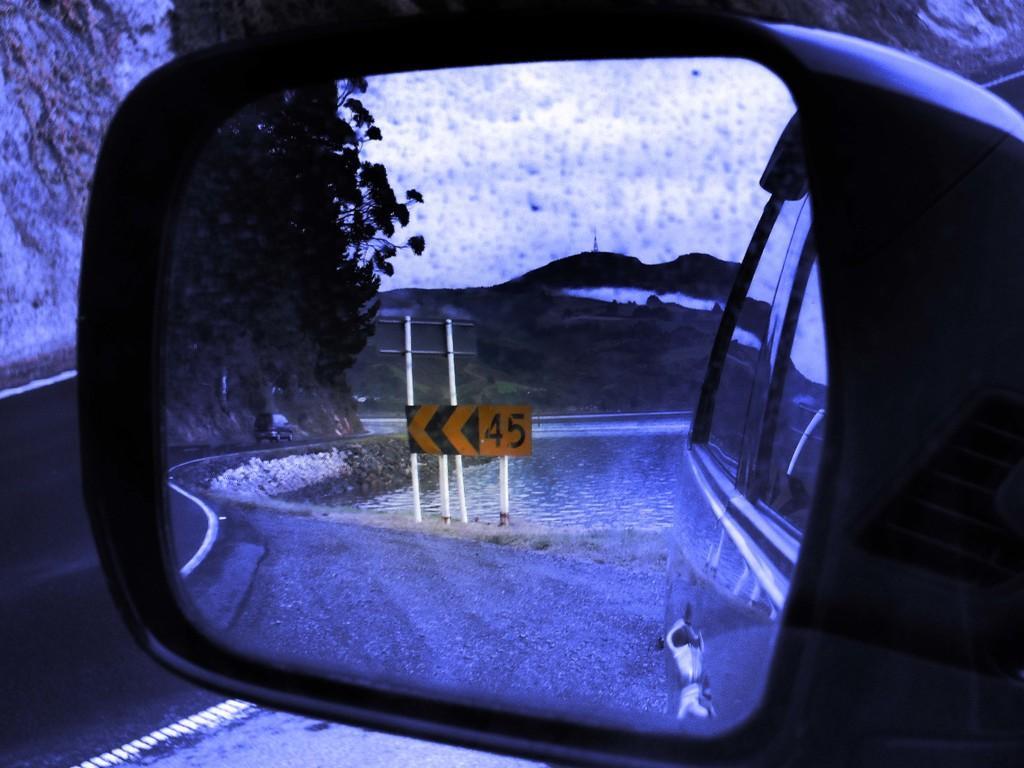Please provide a concise description of this image. There is a mirror. In the mirror we can see poles, board, water, plants, mountain, and sky. 